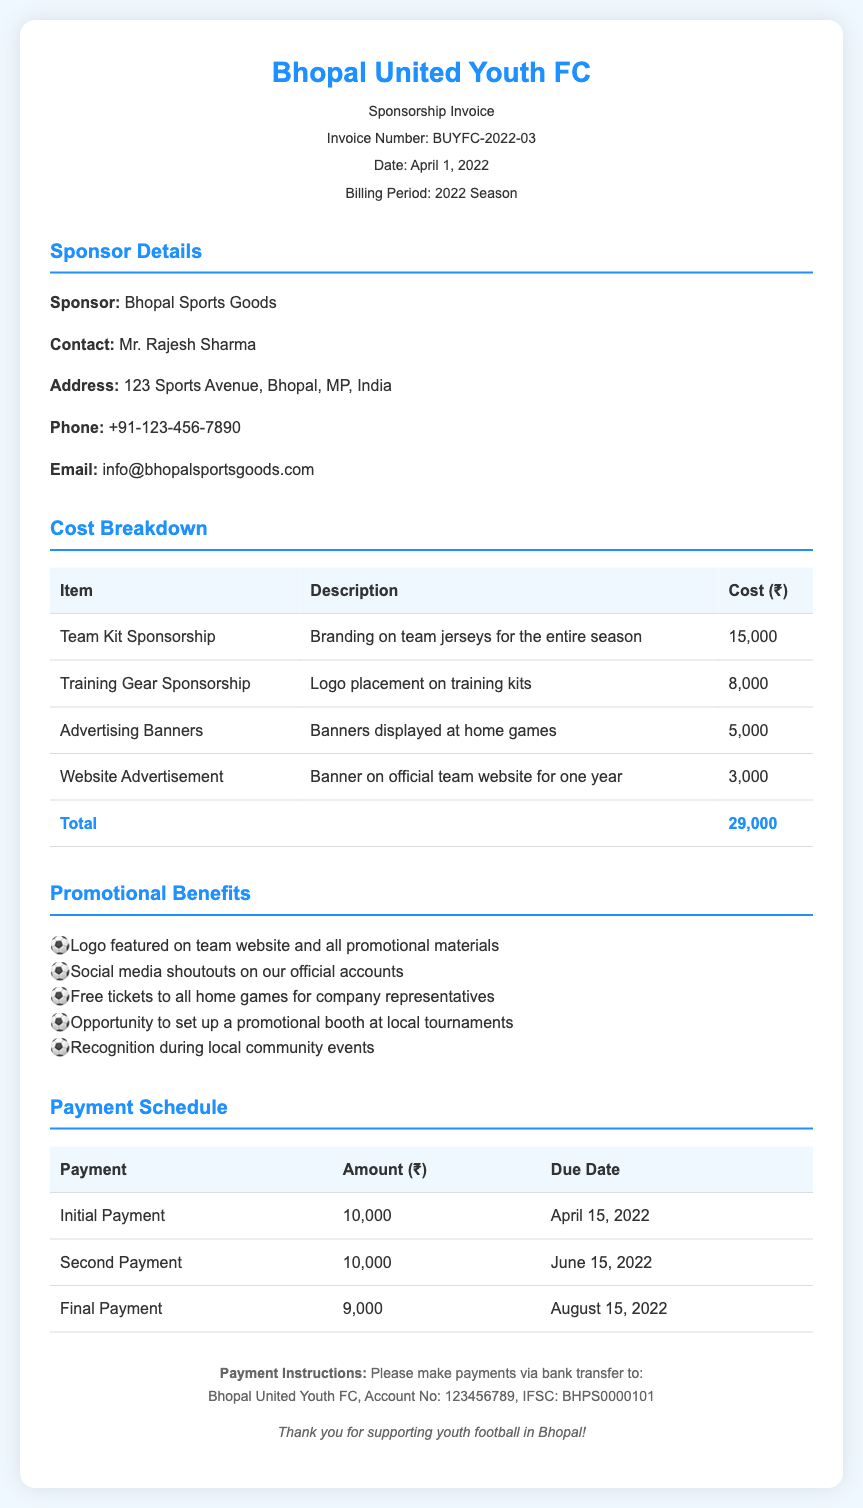What is the invoice number? The invoice number is clearly stated at the top of the document, which is BUYFC-2022-03.
Answer: BUYFC-2022-03 Who is the contact person for the sponsor? The contact person for the sponsor is mentioned in the sponsor details section, which is Mr. Rajesh Sharma.
Answer: Mr. Rajesh Sharma What is the total cost for the sponsorship? The total cost is calculated from the cost breakdown table, which shows the total as 29,000.
Answer: 29,000 When is the final payment due? The final payment due date is specified in the payment schedule section, which is August 15, 2022.
Answer: August 15, 2022 What benefit includes free tickets? The promotional benefits section highlights that free tickets to all home games for company representatives is included.
Answer: Free tickets to all home games How much is the second payment? The second payment amount is listed in the payment schedule table, which is 10,000.
Answer: 10,000 What type of advertising is included on the website? The cost breakdown mentions that there is a banner on the official team website for one year as part of the sponsorship.
Answer: Banner on official team website What is the address of Bhopal Sports Goods? The address is provided in the sponsor details section, which is 123 Sports Avenue, Bhopal, MP, India.
Answer: 123 Sports Avenue, Bhopal, MP, India What color is used for the invoice header? The color used for the invoice header is mentioned in the styling section, which is #1e90ff.
Answer: #1e90ff 